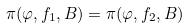Convert formula to latex. <formula><loc_0><loc_0><loc_500><loc_500>\pi ( \varphi , f _ { 1 } , B ) = \pi ( \varphi , f _ { 2 } , B )</formula> 